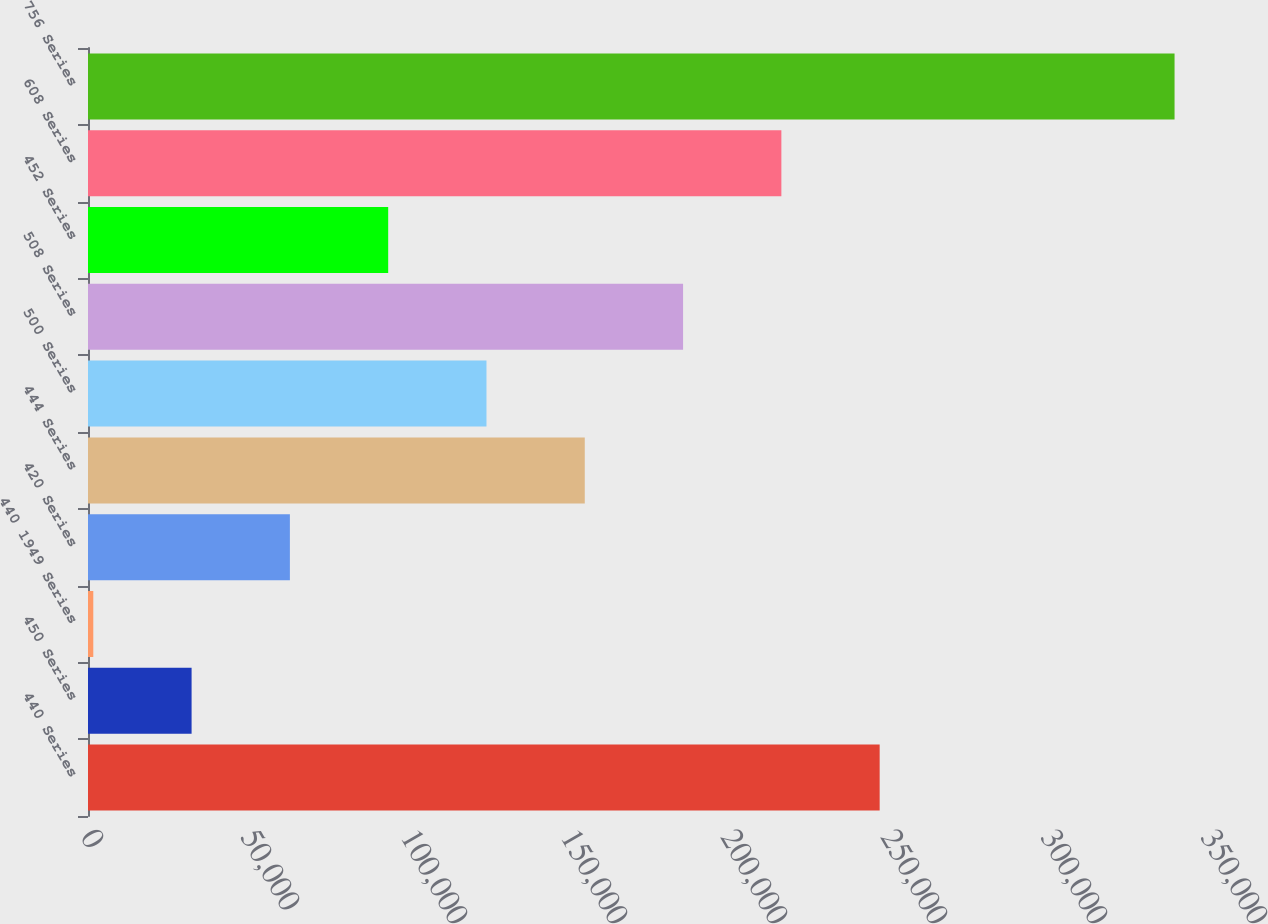<chart> <loc_0><loc_0><loc_500><loc_500><bar_chart><fcel>440 Series<fcel>450 Series<fcel>440 1949 Series<fcel>420 Series<fcel>444 Series<fcel>500 Series<fcel>508 Series<fcel>452 Series<fcel>608 Series<fcel>756 Series<nl><fcel>247395<fcel>32372.5<fcel>1655<fcel>63090<fcel>155242<fcel>124525<fcel>185960<fcel>93807.5<fcel>216678<fcel>339548<nl></chart> 